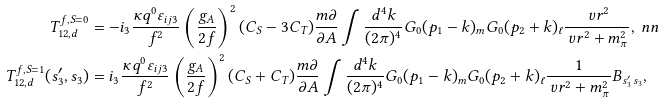Convert formula to latex. <formula><loc_0><loc_0><loc_500><loc_500>T _ { 1 2 , d } ^ { f , S = 0 } & = - i _ { 3 } \frac { \kappa q ^ { 0 } \varepsilon _ { i j 3 } } { f ^ { 2 } } \left ( \frac { g _ { A } } { 2 f } \right ) ^ { 2 } ( C _ { S } - 3 C _ { T } ) \frac { m \partial } { \partial A } \int \frac { d ^ { 4 } k } { ( 2 \pi ) ^ { 4 } } G _ { 0 } ( p _ { 1 } - k ) _ { m } G _ { 0 } ( p _ { 2 } + k ) _ { \ell } \frac { \ v r ^ { 2 } } { \ v r ^ { 2 } + m _ { \pi } ^ { 2 } } , \ n n \\ T _ { 1 2 , d } ^ { f , S = 1 } ( s ^ { \prime } _ { 3 } , s _ { 3 } ) & = i _ { 3 } \frac { \kappa q ^ { 0 } \varepsilon _ { i j 3 } } { f ^ { 2 } } \left ( \frac { g _ { A } } { 2 f } \right ) ^ { 2 } ( C _ { S } + C _ { T } ) \frac { m \partial } { \partial A } \int \frac { d ^ { 4 } k } { ( 2 \pi ) ^ { 4 } } G _ { 0 } ( p _ { 1 } - k ) _ { m } G _ { 0 } ( p _ { 2 } + k ) _ { \ell } \frac { 1 } { \ v r ^ { 2 } + m _ { \pi } ^ { 2 } } B _ { s ^ { \prime } _ { 3 } \, s _ { 3 } } ,</formula> 